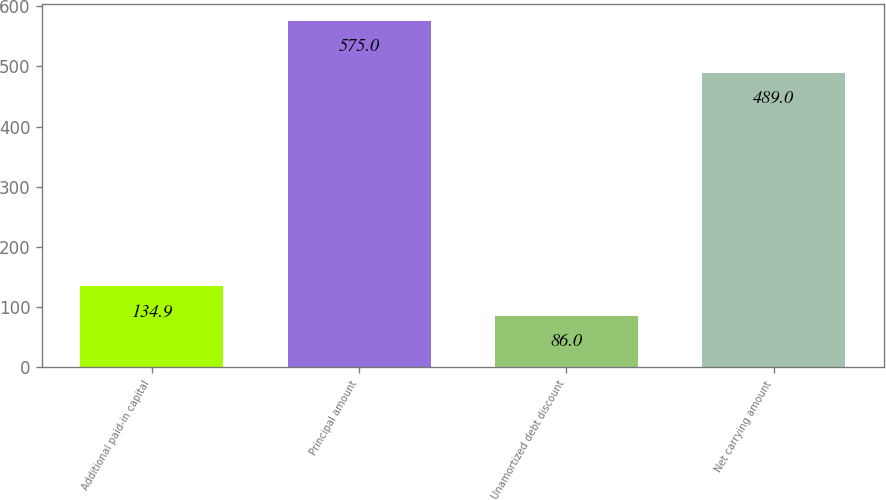<chart> <loc_0><loc_0><loc_500><loc_500><bar_chart><fcel>Additional paid-in capital<fcel>Principal amount<fcel>Unamortized debt discount<fcel>Net carrying amount<nl><fcel>134.9<fcel>575<fcel>86<fcel>489<nl></chart> 